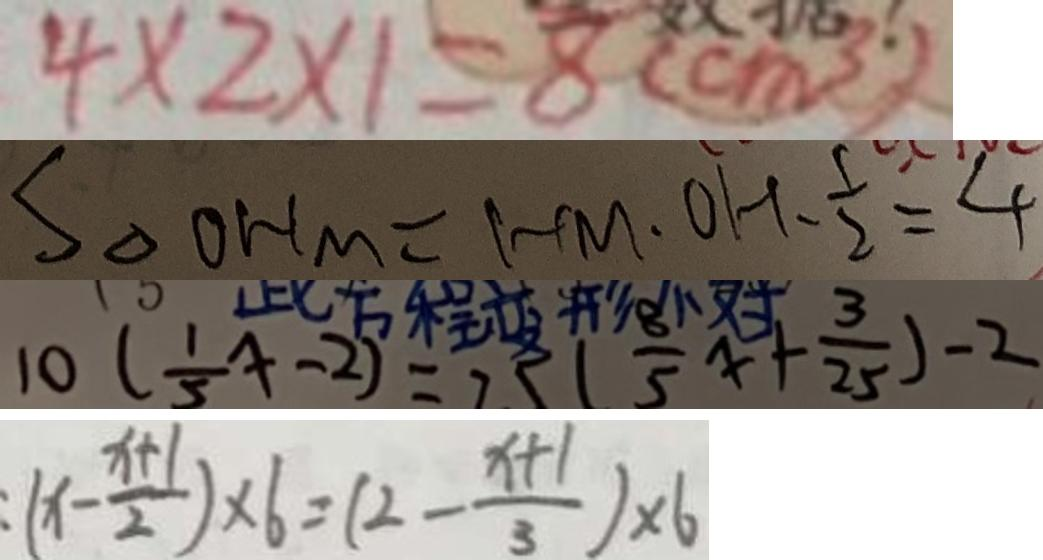<formula> <loc_0><loc_0><loc_500><loc_500>4 \times 2 \times 1 = 8 ( c m ^ { 3 } ) 
 S _ { \Delta O H M } = H M \cdot O H - \frac { 1 } { 2 } = 4 
 1 0 ( \frac { 1 } { 5 } x - 2 ) = 7 5 ( \frac { 8 } { 5 } x + \frac { 3 } { 2 5 } ) - 2 
 ( x - \frac { x + 1 } { 2 } ) \times 6 = ( 2 - \frac { x + 1 } { 3 } ) \times 6</formula> 